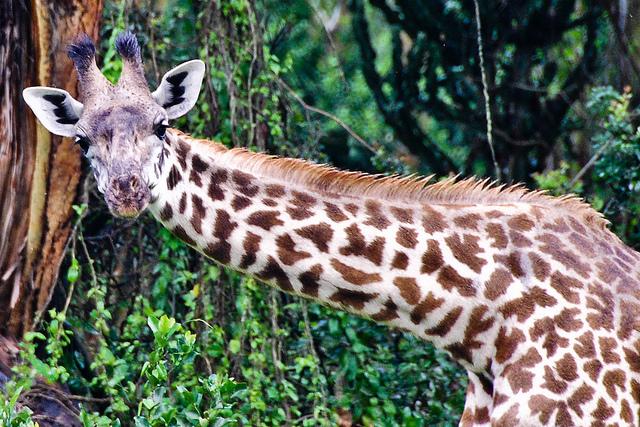What kind of animal is this?
Answer briefly. Giraffe. What color are the leaves?
Short answer required. Green. How many giraffes are in the picture?
Concise answer only. 1. How many ears can you see on this animal?
Short answer required. 2. 